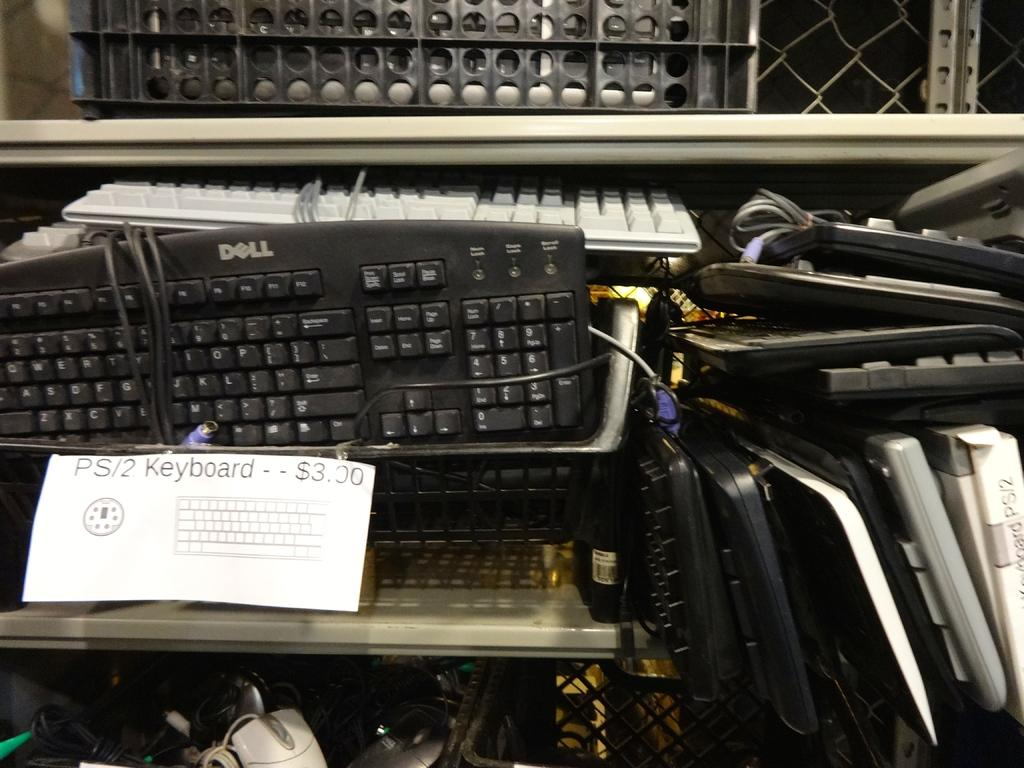<image>
Share a concise interpretation of the image provided. A Dell computer keyboard next to a sign that says "PS/2 keyboard $3.00" 